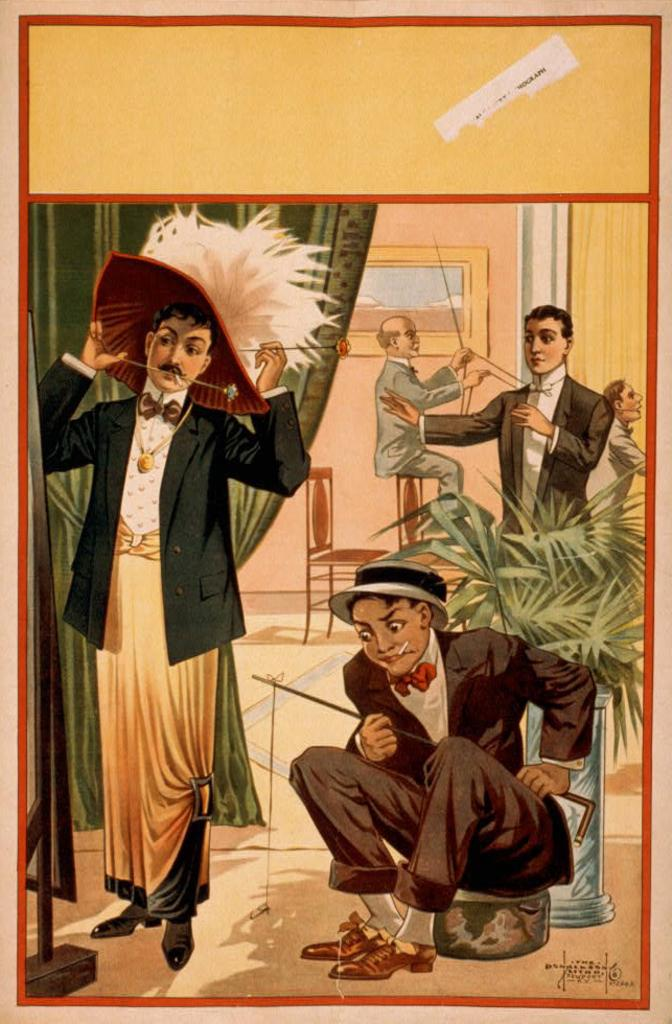What type of content is featured in the image? The image contains animation. What type of map can be seen in the image? There is no map present in the image, as it contains animation. What type of apparel is worn by the characters in the image? There are no characters or apparel visible in the image, as it contains animation. 